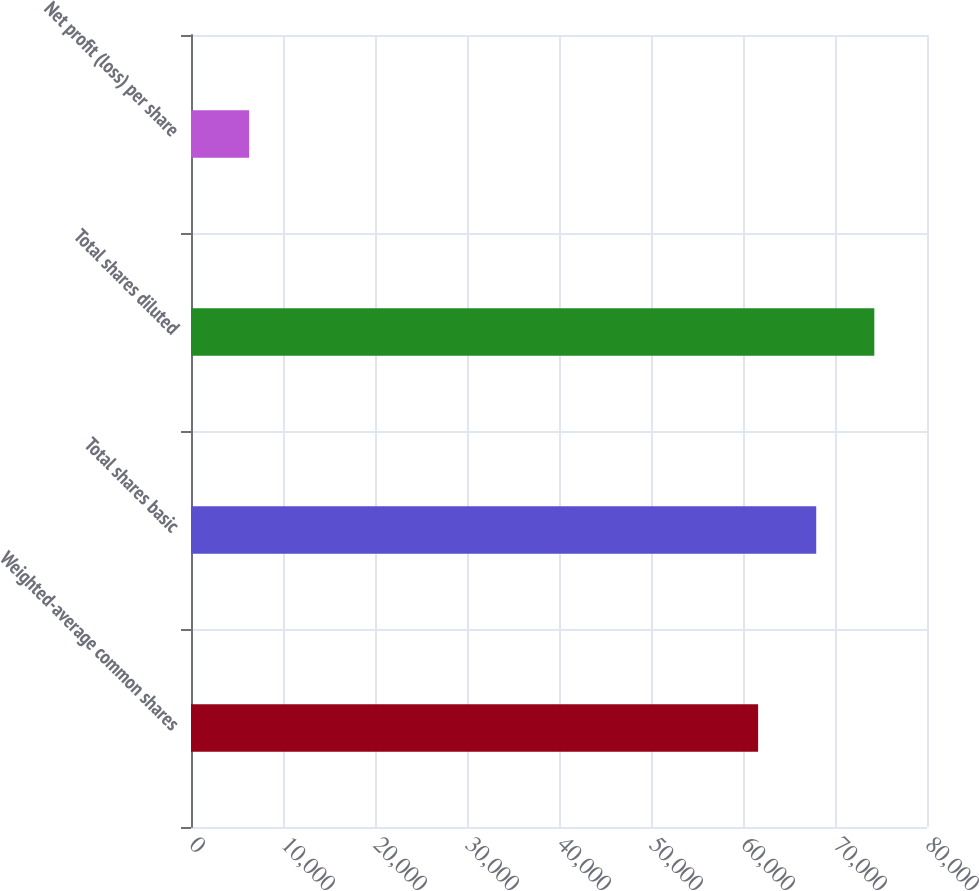Convert chart. <chart><loc_0><loc_0><loc_500><loc_500><bar_chart><fcel>Weighted-average common shares<fcel>Total shares basic<fcel>Total shares diluted<fcel>Net profit (loss) per share<nl><fcel>61644<fcel>67959.2<fcel>74274.4<fcel>6315.22<nl></chart> 